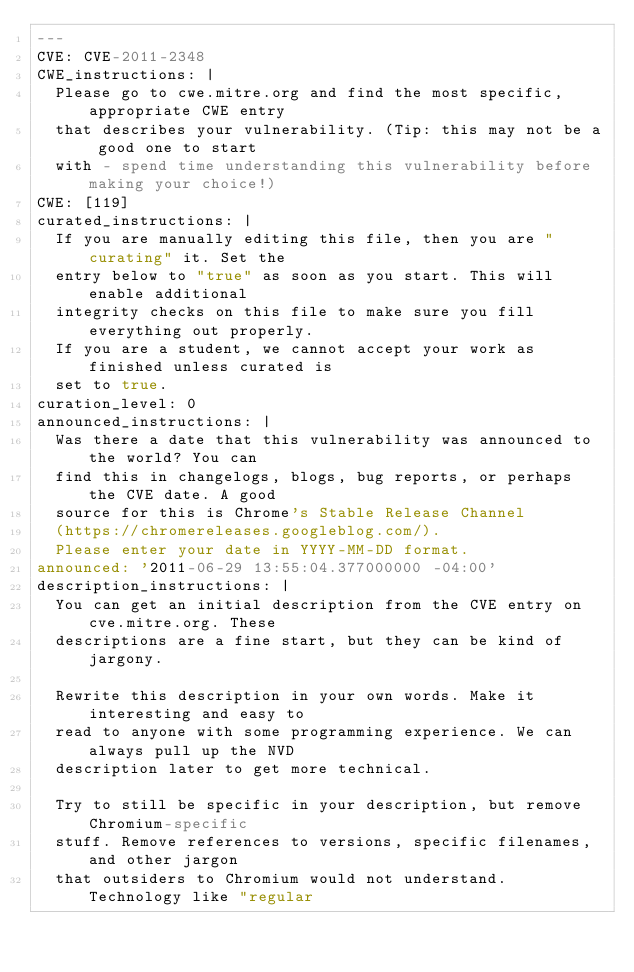<code> <loc_0><loc_0><loc_500><loc_500><_YAML_>---
CVE: CVE-2011-2348
CWE_instructions: |
  Please go to cwe.mitre.org and find the most specific, appropriate CWE entry
  that describes your vulnerability. (Tip: this may not be a good one to start
  with - spend time understanding this vulnerability before making your choice!)
CWE: [119]
curated_instructions: |
  If you are manually editing this file, then you are "curating" it. Set the
  entry below to "true" as soon as you start. This will enable additional
  integrity checks on this file to make sure you fill everything out properly.
  If you are a student, we cannot accept your work as finished unless curated is
  set to true.
curation_level: 0
announced_instructions: |
  Was there a date that this vulnerability was announced to the world? You can
  find this in changelogs, blogs, bug reports, or perhaps the CVE date. A good
  source for this is Chrome's Stable Release Channel
  (https://chromereleases.googleblog.com/).
  Please enter your date in YYYY-MM-DD format.
announced: '2011-06-29 13:55:04.377000000 -04:00'
description_instructions: |
  You can get an initial description from the CVE entry on cve.mitre.org. These
  descriptions are a fine start, but they can be kind of jargony.

  Rewrite this description in your own words. Make it interesting and easy to
  read to anyone with some programming experience. We can always pull up the NVD
  description later to get more technical.

  Try to still be specific in your description, but remove Chromium-specific
  stuff. Remove references to versions, specific filenames, and other jargon
  that outsiders to Chromium would not understand. Technology like "regular</code> 